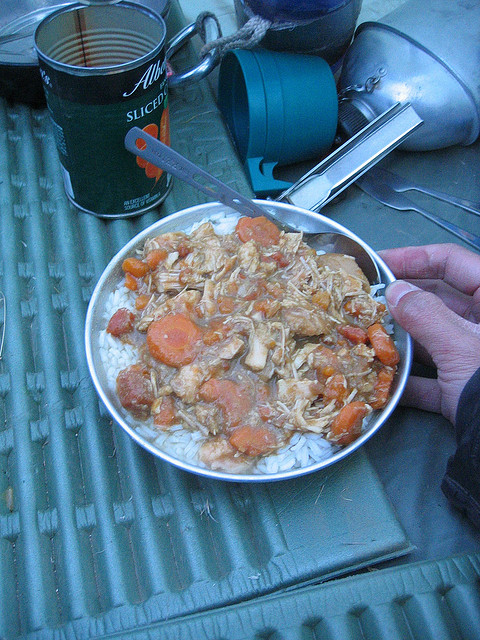<image>What metallic covering is wrapped around an object in the top right corner? It is unknown what metallic covering is wrapped around an object in the top right corner. It is possibly 'canteen', 'tin', 'aluminum', 'can' or 'foil'. Which dish holds an upside down spoon? I don't know which dish holds an upside down spoon. It can be the soup or bowl. What is the purpose of the metal squares on the plate? I don't know the purpose of the metal squares on the plate. They could be for dividing food or acting as handles. What metallic covering is wrapped around an object in the top right corner? I don't know what metallic covering is wrapped around an object in the top right corner. It can be canteen, tin, aluminum, can or foil. Which dish holds an upside down spoon? I am not sure which dish holds an upside down spoon. It can be seen in the soup, bowl, or silver dish. What is the purpose of the metal squares on the plate? It is ambiguous what is the purpose of the metal squares on the plate. It can be to divide different foods or to hold food. 